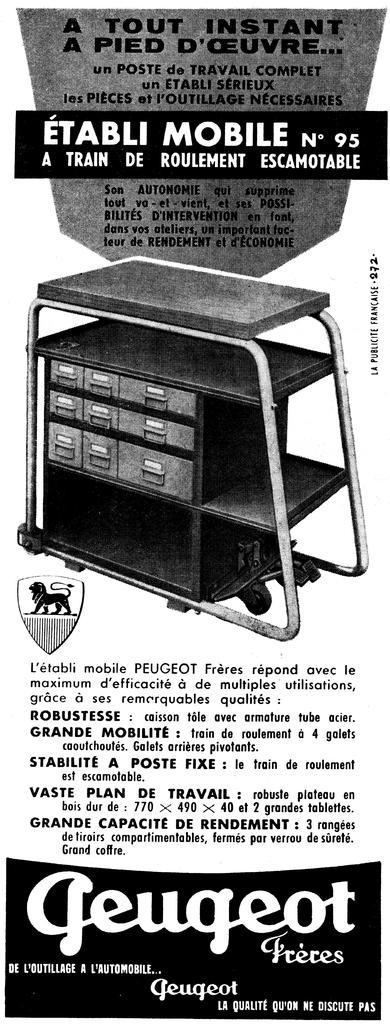<image>
Provide a brief description of the given image. old black and white ad for geugeot freces mobile cart 